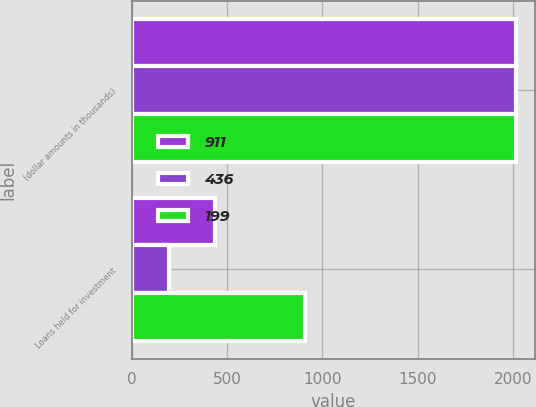Convert chart. <chart><loc_0><loc_0><loc_500><loc_500><stacked_bar_chart><ecel><fcel>(dollar amounts in thousands)<fcel>Loans held for investment<nl><fcel>911<fcel>2016<fcel>436<nl><fcel>436<fcel>2015<fcel>199<nl><fcel>199<fcel>2014<fcel>911<nl></chart> 